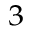<formula> <loc_0><loc_0><loc_500><loc_500>_ { 3 }</formula> 